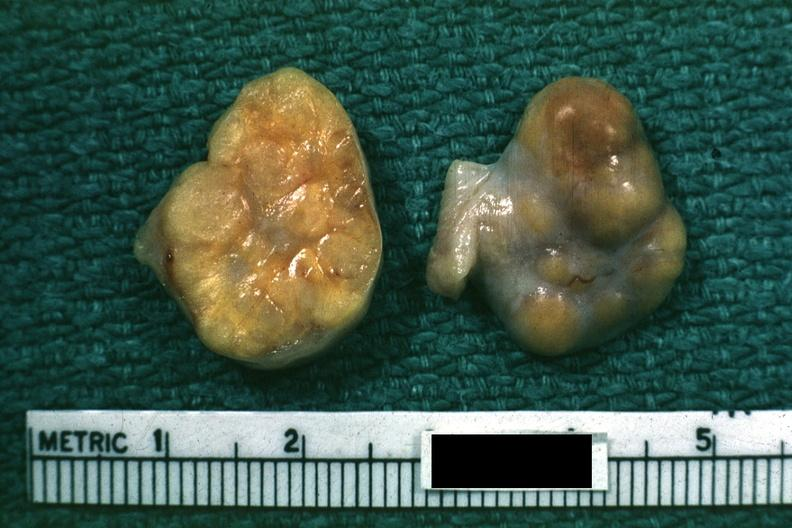what is labeled granulosa cell tumor?
Answer the question using a single word or phrase. This good yellow color slide 